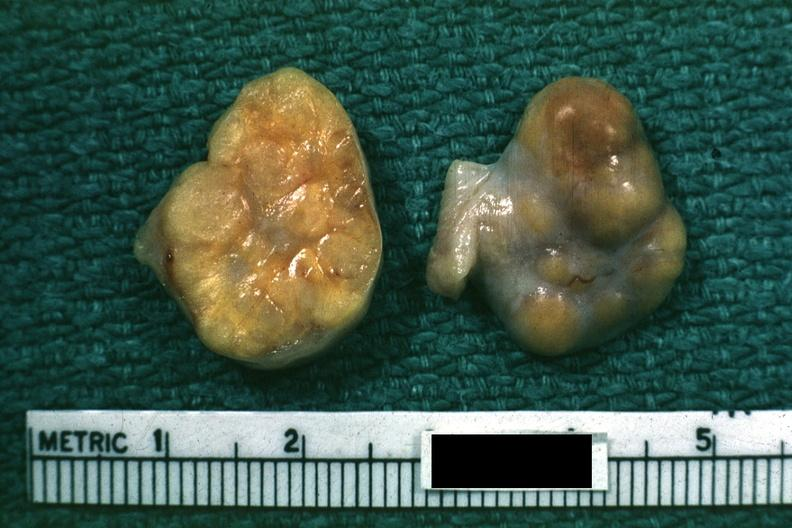what is labeled granulosa cell tumor?
Answer the question using a single word or phrase. This good yellow color slide 